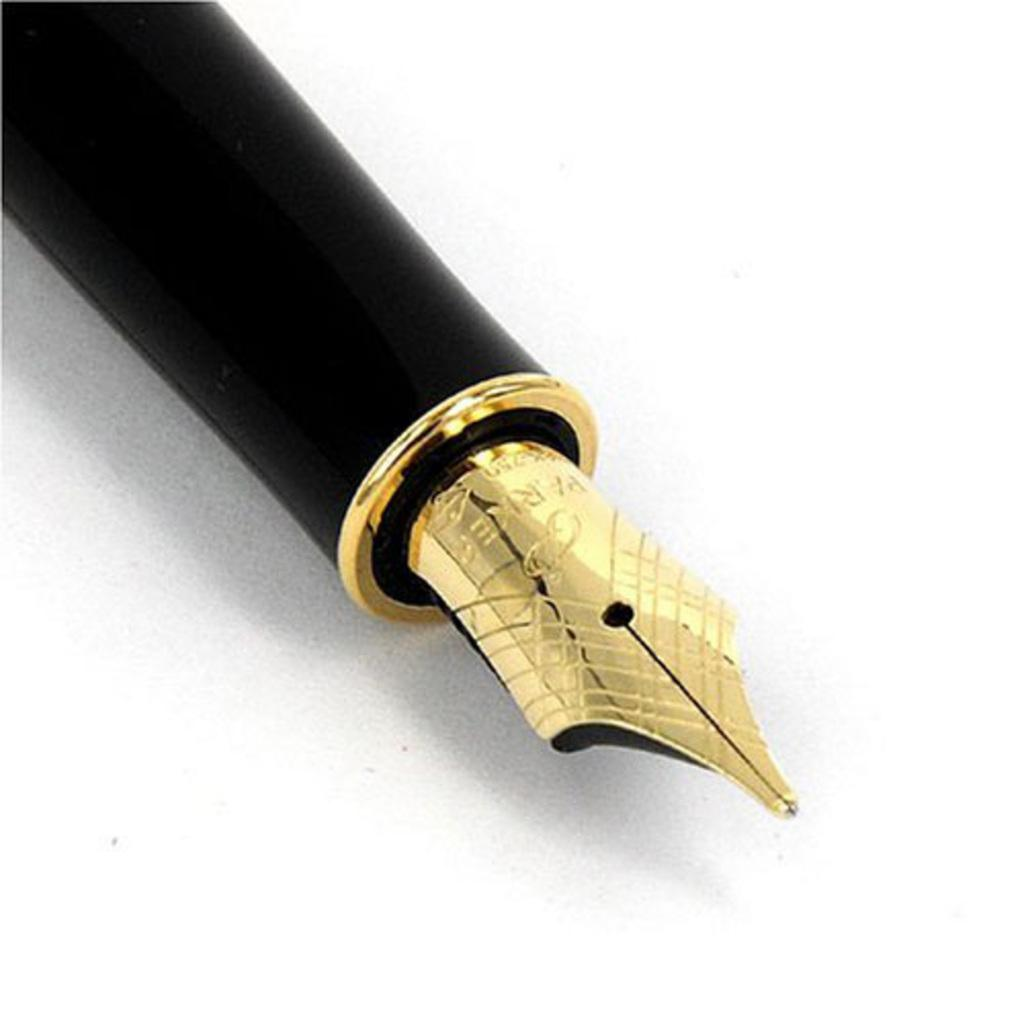What object can be seen in the image? There is an ink pen in the image. What might the ink pen be used for? The ink pen might be used for writing or drawing. Can you describe the appearance of the ink pen? The ink pen appears to be a standard writing instrument with a barrel and a tip for dispensing ink. Who is the friend that the ink pen is offering to in the image? There is no friend or offer present in the image; it only features an ink pen. What type of toothbrush is visible in the image? There is no toothbrush present in the image; it only features an ink pen. 